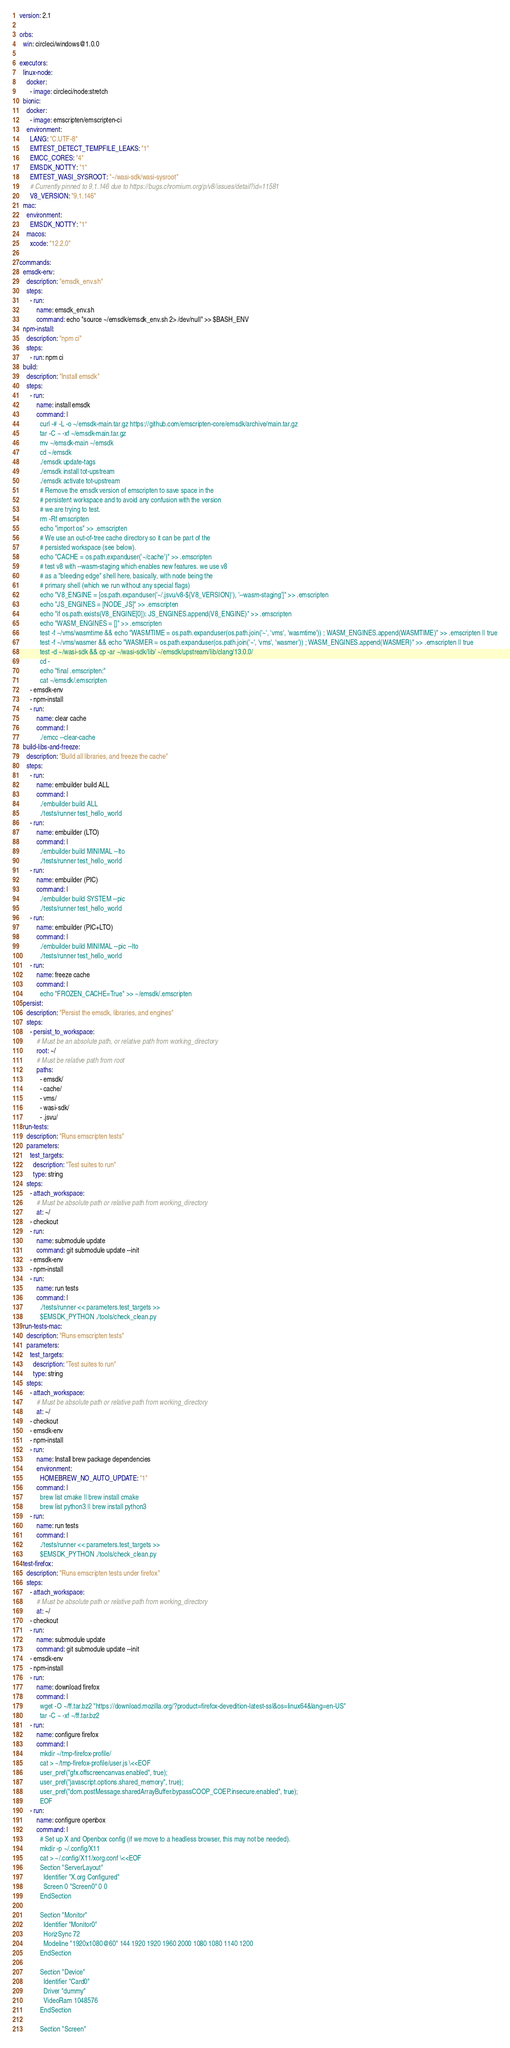<code> <loc_0><loc_0><loc_500><loc_500><_YAML_>version: 2.1

orbs:
  win: circleci/windows@1.0.0

executors:
  linux-node:
    docker:
      - image: circleci/node:stretch
  bionic:
    docker:
      - image: emscripten/emscripten-ci
    environment:
      LANG: "C.UTF-8"
      EMTEST_DETECT_TEMPFILE_LEAKS: "1"
      EMCC_CORES: "4"
      EMSDK_NOTTY: "1"
      EMTEST_WASI_SYSROOT: "~/wasi-sdk/wasi-sysroot"
      # Currently pinned to 9.1.146 due to https://bugs.chromium.org/p/v8/issues/detail?id=11581
      V8_VERSION: "9.1.146"
  mac:
    environment:
      EMSDK_NOTTY: "1"
    macos:
      xcode: "12.2.0"

commands:
  emsdk-env:
    description: "emsdk_env.sh"
    steps:
      - run:
          name: emsdk_env.sh
          command: echo "source ~/emsdk/emsdk_env.sh 2> /dev/null" >> $BASH_ENV
  npm-install:
    description: "npm ci"
    steps:
      - run: npm ci
  build:
    description: "Install emsdk"
    steps:
      - run:
          name: install emsdk
          command: |
            curl -# -L -o ~/emsdk-main.tar.gz https://github.com/emscripten-core/emsdk/archive/main.tar.gz
            tar -C ~ -xf ~/emsdk-main.tar.gz
            mv ~/emsdk-main ~/emsdk
            cd ~/emsdk
            ./emsdk update-tags
            ./emsdk install tot-upstream
            ./emsdk activate tot-upstream
            # Remove the emsdk version of emscripten to save space in the
            # persistent workspace and to avoid any confusion with the version
            # we are trying to test.
            rm -Rf emscripten
            echo "import os" >> .emscripten
            # We use an out-of-tree cache directory so it can be part of the
            # persisted workspace (see below).
            echo "CACHE = os.path.expanduser('~/cache')" >> .emscripten
            # test v8 with --wasm-staging which enables new features. we use v8
            # as a "bleeding edge" shell here, basically, with node being the
            # primary shell (which we run without any special flags)
            echo "V8_ENGINE = [os.path.expanduser('~/.jsvu/v8-${V8_VERSION}'), '--wasm-staging']" >> .emscripten
            echo "JS_ENGINES = [NODE_JS]" >> .emscripten
            echo "if os.path.exists(V8_ENGINE[0]): JS_ENGINES.append(V8_ENGINE)" >> .emscripten
            echo "WASM_ENGINES = []" >> .emscripten
            test -f ~/vms/wasmtime && echo "WASMTIME = os.path.expanduser(os.path.join('~', 'vms', 'wasmtime')) ; WASM_ENGINES.append(WASMTIME)" >> .emscripten || true
            test -f ~/vms/wasmer && echo "WASMER = os.path.expanduser(os.path.join('~', 'vms', 'wasmer')) ; WASM_ENGINES.append(WASMER)" >> .emscripten || true
            test -d ~/wasi-sdk && cp -ar ~/wasi-sdk/lib/ ~/emsdk/upstream/lib/clang/13.0.0/
            cd -
            echo "final .emscripten:"
            cat ~/emsdk/.emscripten
      - emsdk-env
      - npm-install
      - run:
          name: clear cache
          command: |
            ./emcc --clear-cache
  build-libs-and-freeze:
    description: "Build all libraries, and freeze the cache"
    steps:
      - run:
          name: embuilder build ALL
          command: |
            ./embuilder build ALL
            ./tests/runner test_hello_world
      - run:
          name: embuilder (LTO)
          command: |
            ./embuilder build MINIMAL --lto
            ./tests/runner test_hello_world
      - run:
          name: embuilder (PIC)
          command: |
            ./embuilder build SYSTEM --pic
            ./tests/runner test_hello_world
      - run:
          name: embuilder (PIC+LTO)
          command: |
            ./embuilder build MINIMAL --pic --lto
            ./tests/runner test_hello_world
      - run:
          name: freeze cache
          command: |
            echo "FROZEN_CACHE=True" >> ~/emsdk/.emscripten
  persist:
    description: "Persist the emsdk, libraries, and engines"
    steps:
      - persist_to_workspace:
          # Must be an absolute path, or relative path from working_directory
          root: ~/
          # Must be relative path from root
          paths:
            - emsdk/
            - cache/
            - vms/
            - wasi-sdk/
            - .jsvu/
  run-tests:
    description: "Runs emscripten tests"
    parameters:
      test_targets:
        description: "Test suites to run"
        type: string
    steps:
      - attach_workspace:
          # Must be absolute path or relative path from working_directory
          at: ~/
      - checkout
      - run:
          name: submodule update
          command: git submodule update --init
      - emsdk-env
      - npm-install
      - run:
          name: run tests
          command: |
            ./tests/runner << parameters.test_targets >>
            $EMSDK_PYTHON ./tools/check_clean.py
  run-tests-mac:
    description: "Runs emscripten tests"
    parameters:
      test_targets:
        description: "Test suites to run"
        type: string
    steps:
      - attach_workspace:
          # Must be absolute path or relative path from working_directory
          at: ~/
      - checkout
      - emsdk-env
      - npm-install
      - run:
          name: Install brew package dependencies
          environment:
            HOMEBREW_NO_AUTO_UPDATE: "1"
          command: |
            brew list cmake || brew install cmake
            brew list python3 || brew install python3
      - run:
          name: run tests
          command: |
            ./tests/runner << parameters.test_targets >>
            $EMSDK_PYTHON ./tools/check_clean.py
  test-firefox:
    description: "Runs emscripten tests under firefox"
    steps:
      - attach_workspace:
          # Must be absolute path or relative path from working_directory
          at: ~/
      - checkout
      - run:
          name: submodule update
          command: git submodule update --init
      - emsdk-env
      - npm-install
      - run:
          name: download firefox
          command: |
            wget -O ~/ff.tar.bz2 "https://download.mozilla.org/?product=firefox-devedition-latest-ssl&os=linux64&lang=en-US"
            tar -C ~ -xf ~/ff.tar.bz2
      - run:
          name: configure firefox
          command: |
            mkdir ~/tmp-firefox-profile/
            cat > ~/tmp-firefox-profile/user.js \<<EOF
            user_pref("gfx.offscreencanvas.enabled", true);
            user_pref("javascript.options.shared_memory", true);
            user_pref("dom.postMessage.sharedArrayBuffer.bypassCOOP_COEP.insecure.enabled", true);
            EOF
      - run:
          name: configure openbox
          command: |
            # Set up X and Openbox config (if we move to a headless browser, this may not be needed).
            mkdir -p ~/.config/X11
            cat > ~/.config/X11/xorg.conf \<<EOF
            Section "ServerLayout"
              Identifier "X.org Configured"
              Screen 0 "Screen0" 0 0
            EndSection

            Section "Monitor"
              Identifier "Monitor0"
              HorizSync 72
              Modeline "1920x1080@60" 144 1920 1920 1960 2000 1080 1080 1140 1200
            EndSection

            Section "Device"
              Identifier "Card0"
              Driver "dummy"
              VideoRam 1048576
            EndSection

            Section "Screen"</code> 